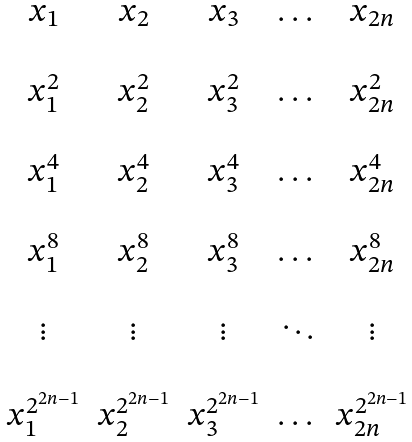Convert formula to latex. <formula><loc_0><loc_0><loc_500><loc_500>\begin{matrix} x _ { 1 } & x _ { 2 } & x _ { 3 } & \dots & x _ { 2 n } \\ \\ x _ { 1 } ^ { 2 } & x _ { 2 } ^ { 2 } & x _ { 3 } ^ { 2 } & \dots & x _ { 2 n } ^ { 2 } \\ \\ x _ { 1 } ^ { 4 } & x _ { 2 } ^ { 4 } & x _ { 3 } ^ { 4 } & \dots & x _ { 2 n } ^ { 4 } \\ \\ x _ { 1 } ^ { 8 } & x _ { 2 } ^ { 8 } & x _ { 3 } ^ { 8 } & \dots & x _ { 2 n } ^ { 8 } \\ \\ \vdots & \vdots & \vdots & \ddots & \vdots \\ \\ x _ { 1 } ^ { 2 ^ { 2 n - 1 } } & x _ { 2 } ^ { 2 ^ { 2 n - 1 } } & x _ { 3 } ^ { 2 ^ { 2 n - 1 } } & \dots & x _ { 2 n } ^ { 2 ^ { 2 n - 1 } } \\ \end{matrix}</formula> 